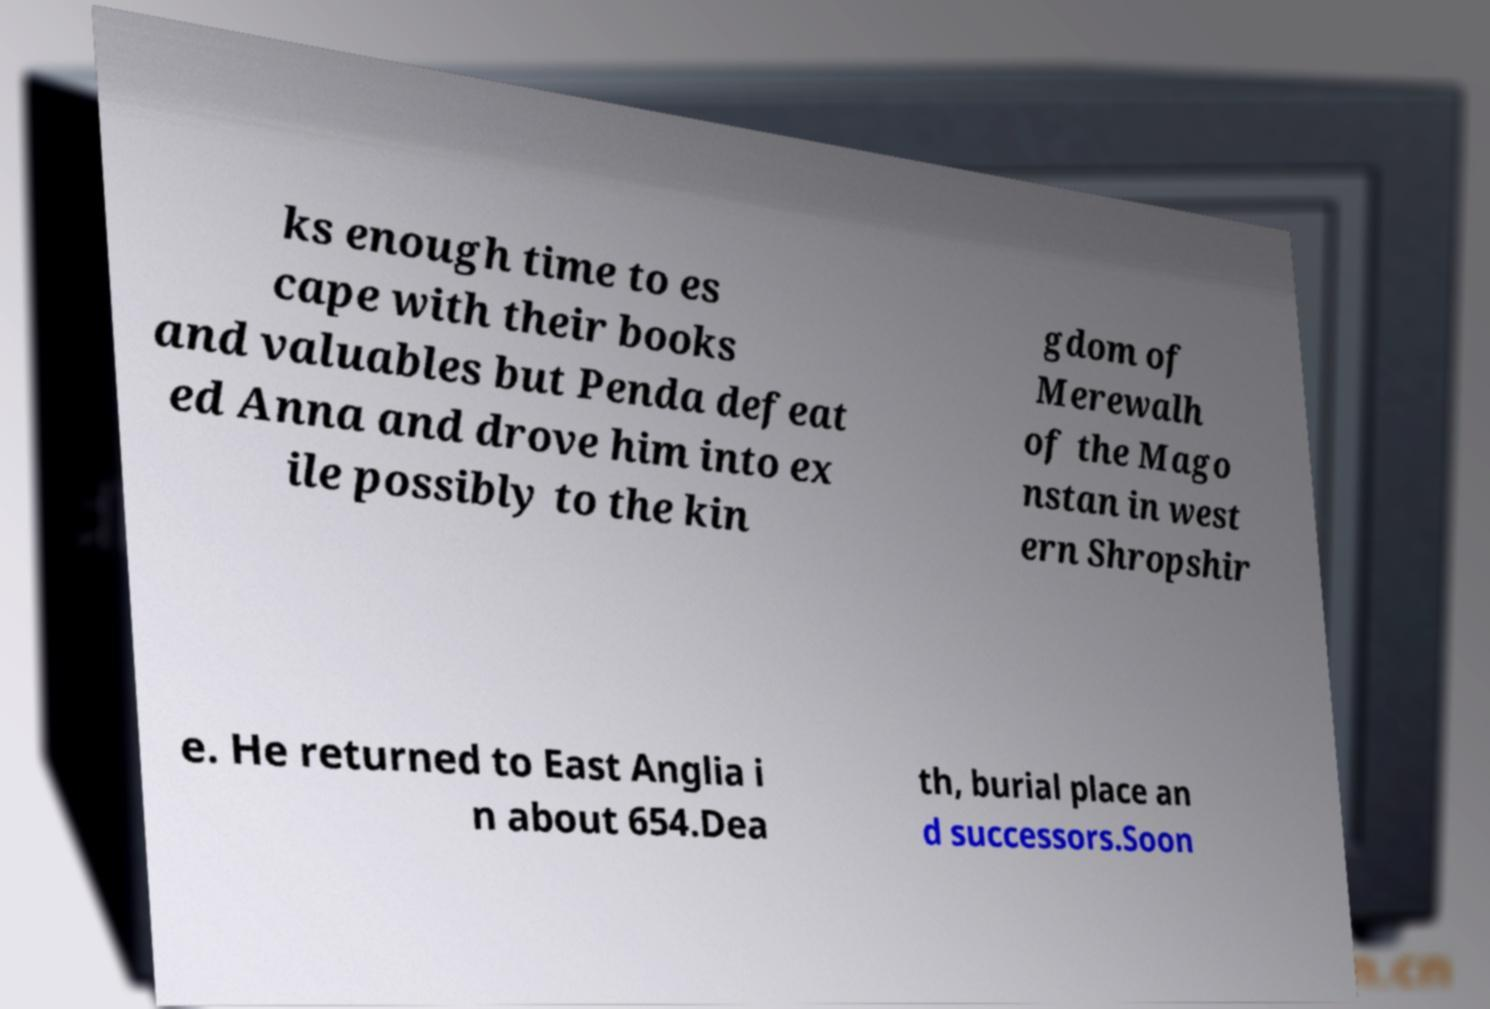For documentation purposes, I need the text within this image transcribed. Could you provide that? ks enough time to es cape with their books and valuables but Penda defeat ed Anna and drove him into ex ile possibly to the kin gdom of Merewalh of the Mago nstan in west ern Shropshir e. He returned to East Anglia i n about 654.Dea th, burial place an d successors.Soon 